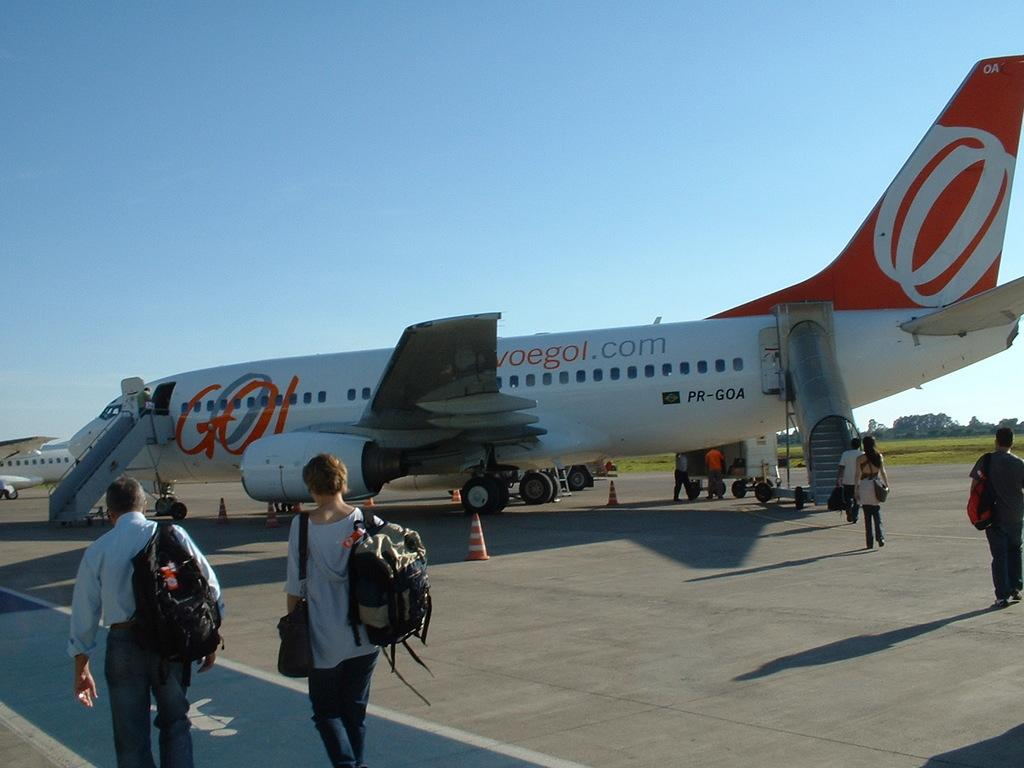<image>
Relay a brief, clear account of the picture shown. A plane is on a runway with a .com website printed on the side. 